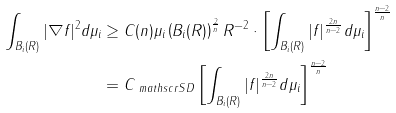Convert formula to latex. <formula><loc_0><loc_0><loc_500><loc_500>\int _ { B _ { i } ( R ) } | \nabla f | ^ { 2 } d \mu _ { i } & \geq C ( n ) \mu _ { i } \left ( B _ { i } ( R ) \right ) ^ { \frac { 2 } { n } } R ^ { - 2 } \cdot \left [ \int _ { B _ { i } ( R ) } | f | ^ { \frac { 2 n } { n - 2 } } d \mu _ { i } \right ] ^ { \frac { n - 2 } { n } } \\ & = C _ { \ m a t h s c r { S D } } \left [ \int _ { B _ { i } ( R ) } | f | ^ { \frac { 2 n } { n - 2 } } d \mu _ { i } \right ] ^ { \frac { n - 2 } { n } }</formula> 